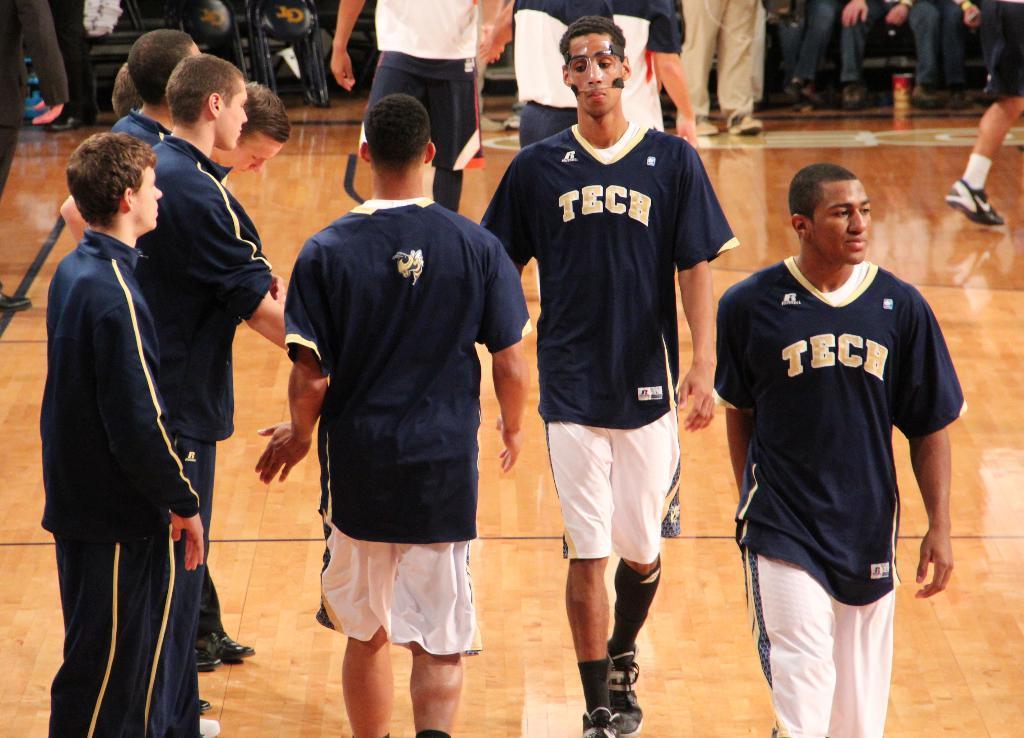How would you summarize this image in a sentence or two? In this picture I can see few people walking and few are standing and looks like few people are sitting in the chairs in the back. 